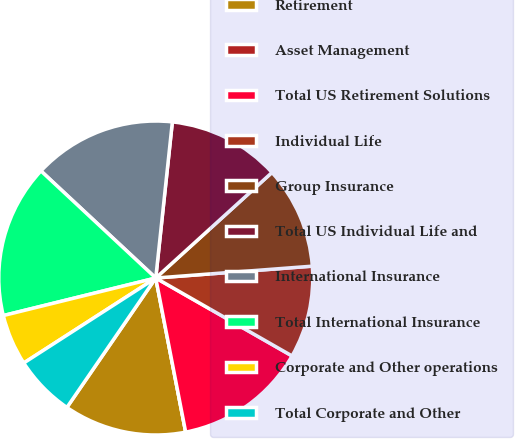<chart> <loc_0><loc_0><loc_500><loc_500><pie_chart><fcel>Retirement<fcel>Asset Management<fcel>Total US Retirement Solutions<fcel>Individual Life<fcel>Group Insurance<fcel>Total US Individual Life and<fcel>International Insurance<fcel>Total International Insurance<fcel>Corporate and Other operations<fcel>Total Corporate and Other<nl><fcel>12.63%<fcel>0.0%<fcel>13.68%<fcel>9.47%<fcel>10.53%<fcel>11.58%<fcel>14.74%<fcel>15.79%<fcel>5.26%<fcel>6.32%<nl></chart> 